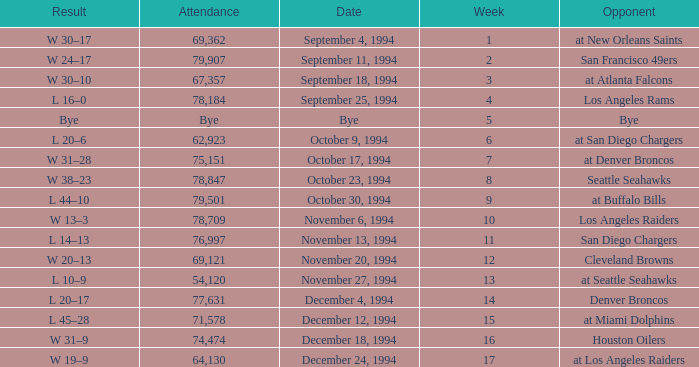What was the score of the Chiefs November 27, 1994 game? L 10–9. 